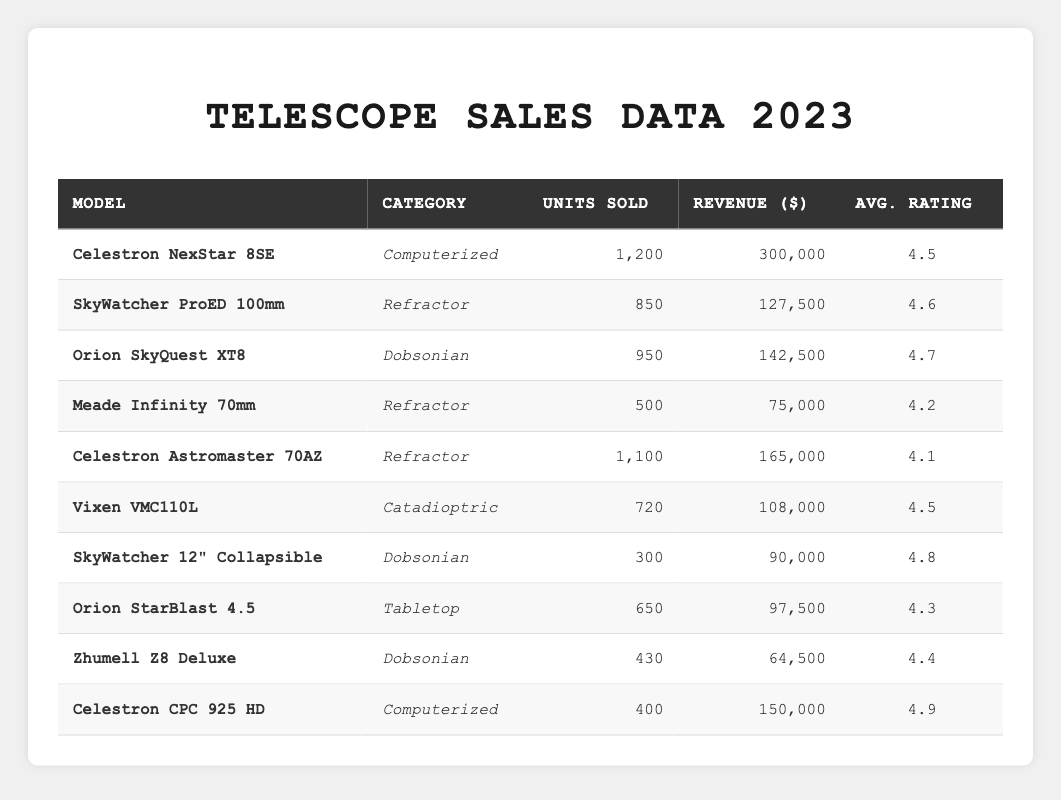What is the total revenue generated by all telescope models? To find the total revenue, sum the revenue of each model: 300000 + 127500 + 142500 + 75000 + 165000 + 108000 + 90000 + 97500 + 64500 + 150000 = 1,254,000.
Answer: 1,254,000 Which model has the highest average rating? The average ratings for each model are provided. The highest is 4.9 for the Celestron CPC 925 HD.
Answer: Celestron CPC 925 HD How many more units did the Celestron NexStar 8SE sell compared to the Celestron CPC 925 HD? The units sold for Celestron NexStar 8SE is 1200, while Celestron CPC 925 HD sold 400. Therefore, the difference is 1200 - 400 = 800.
Answer: 800 What is the average rating of the refractor category telescopes? Sum the average ratings of the refractor models (4.6 for SkyWatcher ProED 100mm, 4.2 for Meade Infinity 70mm, and 4.1 for Celestron Astromaster 70AZ) to get 4.6 + 4.2 + 4.1 = 13. Average is 13/3 = 4.33.
Answer: 4.33 Did the Celestron Astromaster 70AZ generate more revenue than the Meade Infinity 70mm? The revenue for Celestron Astromaster 70AZ is 165000 and for Meade Infinity 70mm is 75000. Since 165000 > 75000, the statement is true.
Answer: Yes What is the total number of units sold for Dobsonian category telescopes? The total units sold for Dobsonian models are 950 (Orion SkyQuest XT8) + 300 (SkyWatcher 12” Collapsible) + 430 (Zhumell Z8 Deluxe) = 1680.
Answer: 1680 Which category of telescopes sold the least number of units? Observing the units sold, the Dobsonian category has 1680 units, followed by Refractor at 2350, Computerized at 1600, and Catadioptric at 720. The Catadioptric category has the least units sold with 720.
Answer: Catadioptric What is the revenue difference between the best-selling model and the second-best-selling model? The best-selling model is Celestron NexStar 8SE with revenue 300000, and the second-best-sold is Celestron Astromaster 70AZ with revenue 165000. The difference is 300000 - 165000 = 135000.
Answer: 135000 Which model sold exactly 650 units? Referring to the units sold for each model, only the Orion StarBlast 4.5 sold 650 units.
Answer: Orion StarBlast 4.5 How many models generated revenue over 100,000? The models generating over 100,000 revenue are: Celestron NexStar 8SE, Celestron Astromaster 70AZ, Orion SkyQuest XT8, and Celestron CPC 925 HD. There are 4 such models.
Answer: 4 What is the average number of units sold across all telescope models? To find the average units sold, sum the units: 1200 + 850 + 950 + 500 + 1100 + 720 + 300 + 650 + 430 + 400 = 5,100. The average is 5100/10 = 510.
Answer: 510 